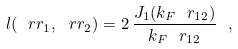<formula> <loc_0><loc_0><loc_500><loc_500>l ( \ r r _ { 1 } , \ r r _ { 2 } ) = 2 \, \frac { J _ { 1 } ( k _ { F } \ r _ { 1 2 } ) } { k _ { F } \ r _ { 1 2 } } \ ,</formula> 